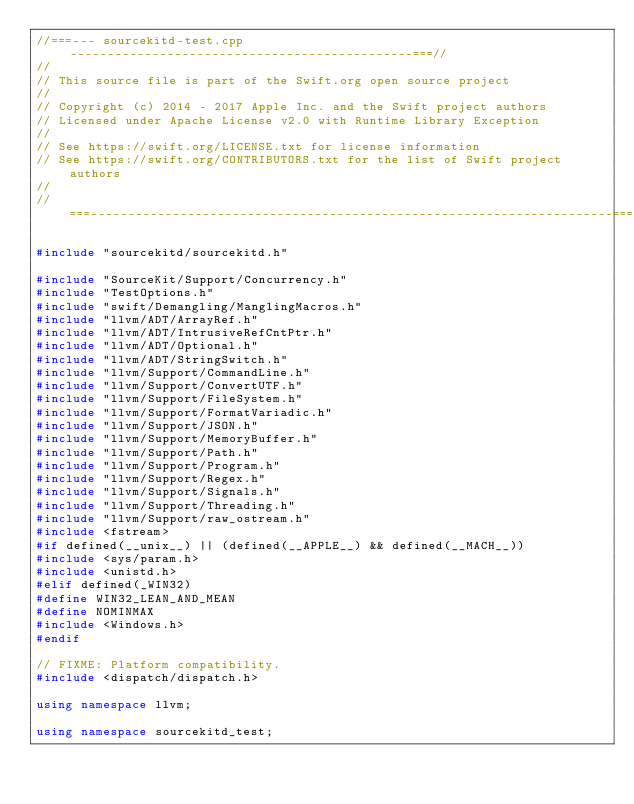Convert code to text. <code><loc_0><loc_0><loc_500><loc_500><_C++_>//===--- sourcekitd-test.cpp ----------------------------------------------===//
//
// This source file is part of the Swift.org open source project
//
// Copyright (c) 2014 - 2017 Apple Inc. and the Swift project authors
// Licensed under Apache License v2.0 with Runtime Library Exception
//
// See https://swift.org/LICENSE.txt for license information
// See https://swift.org/CONTRIBUTORS.txt for the list of Swift project authors
//
//===----------------------------------------------------------------------===//

#include "sourcekitd/sourcekitd.h"

#include "SourceKit/Support/Concurrency.h"
#include "TestOptions.h"
#include "swift/Demangling/ManglingMacros.h"
#include "llvm/ADT/ArrayRef.h"
#include "llvm/ADT/IntrusiveRefCntPtr.h"
#include "llvm/ADT/Optional.h"
#include "llvm/ADT/StringSwitch.h"
#include "llvm/Support/CommandLine.h"
#include "llvm/Support/ConvertUTF.h"
#include "llvm/Support/FileSystem.h"
#include "llvm/Support/FormatVariadic.h"
#include "llvm/Support/JSON.h"
#include "llvm/Support/MemoryBuffer.h"
#include "llvm/Support/Path.h"
#include "llvm/Support/Program.h"
#include "llvm/Support/Regex.h"
#include "llvm/Support/Signals.h"
#include "llvm/Support/Threading.h"
#include "llvm/Support/raw_ostream.h"
#include <fstream>
#if defined(__unix__) || (defined(__APPLE__) && defined(__MACH__))
#include <sys/param.h>
#include <unistd.h>
#elif defined(_WIN32)
#define WIN32_LEAN_AND_MEAN
#define NOMINMAX
#include <Windows.h>
#endif

// FIXME: Platform compatibility.
#include <dispatch/dispatch.h>

using namespace llvm;

using namespace sourcekitd_test;
</code> 